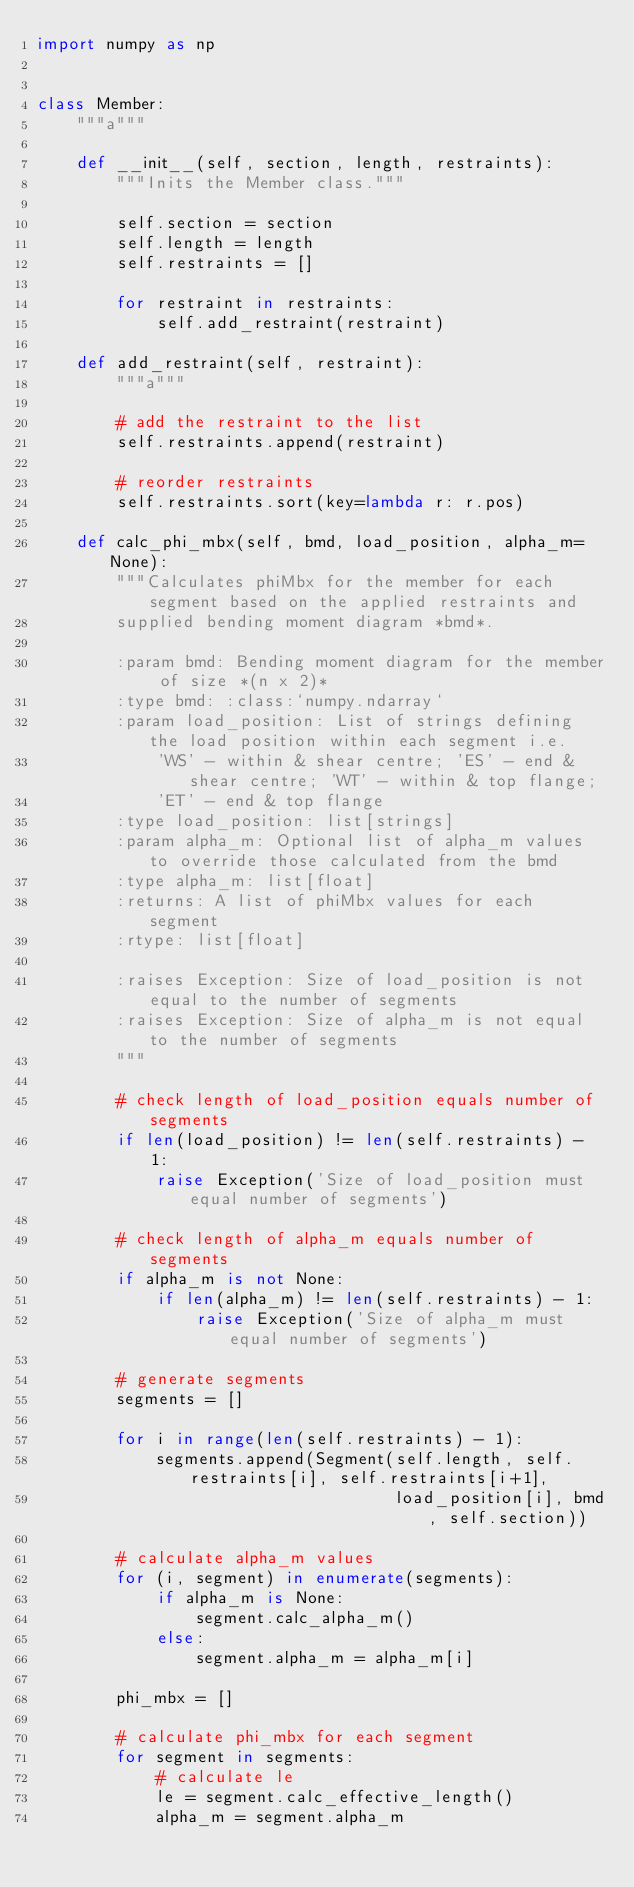Convert code to text. <code><loc_0><loc_0><loc_500><loc_500><_Python_>import numpy as np


class Member:
    """a"""

    def __init__(self, section, length, restraints):
        """Inits the Member class."""

        self.section = section
        self.length = length
        self.restraints = []

        for restraint in restraints:
            self.add_restraint(restraint)

    def add_restraint(self, restraint):
        """a"""

        # add the restraint to the list
        self.restraints.append(restraint)

        # reorder restraints
        self.restraints.sort(key=lambda r: r.pos)

    def calc_phi_mbx(self, bmd, load_position, alpha_m=None):
        """Calculates phiMbx for the member for each segment based on the applied restraints and
        supplied bending moment diagram *bmd*.

        :param bmd: Bending moment diagram for the member of size *(n x 2)*
        :type bmd: :class:`numpy.ndarray`
        :param load_position: List of strings defining the load position within each segment i.e.
            'WS' - within & shear centre; 'ES' - end & shear centre; 'WT' - within & top flange;
            'ET' - end & top flange
        :type load_position: list[strings]
        :param alpha_m: Optional list of alpha_m values to override those calculated from the bmd
        :type alpha_m: list[float]
        :returns: A list of phiMbx values for each segment
        :rtype: list[float]

        :raises Exception: Size of load_position is not equal to the number of segments
        :raises Exception: Size of alpha_m is not equal to the number of segments
        """

        # check length of load_position equals number of segments
        if len(load_position) != len(self.restraints) - 1:
            raise Exception('Size of load_position must equal number of segments')

        # check length of alpha_m equals number of segments
        if alpha_m is not None:
            if len(alpha_m) != len(self.restraints) - 1:
                raise Exception('Size of alpha_m must equal number of segments')

        # generate segments
        segments = []

        for i in range(len(self.restraints) - 1):
            segments.append(Segment(self.length, self.restraints[i], self.restraints[i+1],
                                    load_position[i], bmd, self.section))

        # calculate alpha_m values
        for (i, segment) in enumerate(segments):
            if alpha_m is None:
                segment.calc_alpha_m()
            else:
                segment.alpha_m = alpha_m[i]

        phi_mbx = []

        # calculate phi_mbx for each segment
        for segment in segments:
            # calculate le
            le = segment.calc_effective_length()
            alpha_m = segment.alpha_m
</code> 